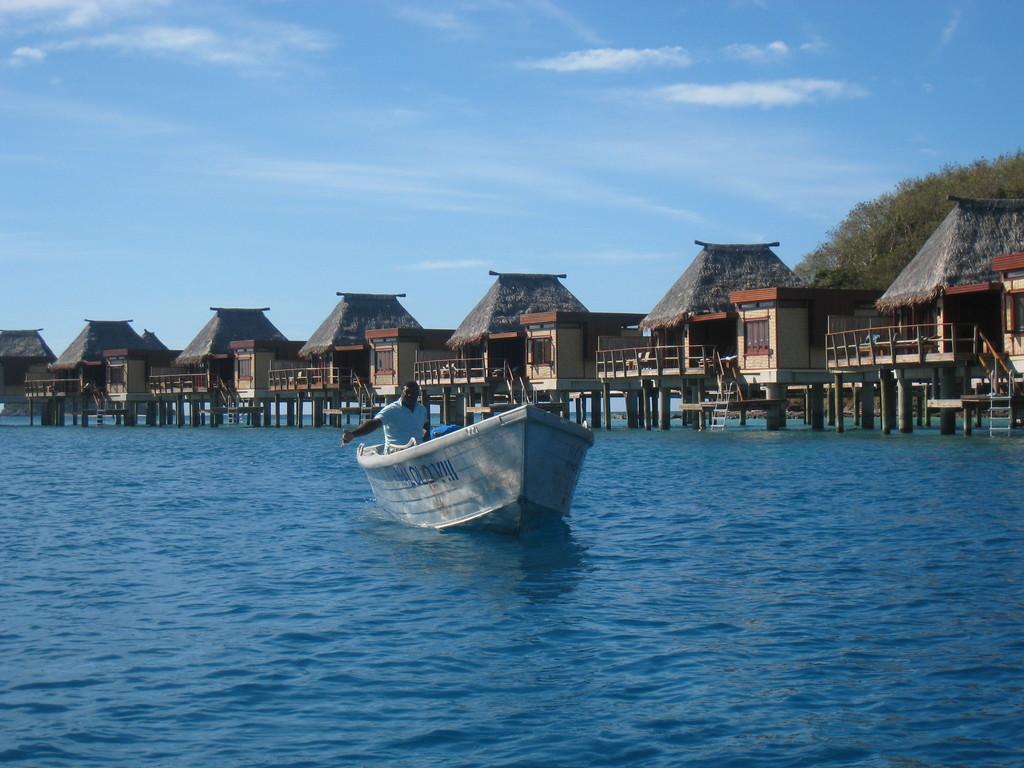Please provide a concise description of this image. The man in white T-shirt is sailing boat in the water. Behind that, there are huts and staircases. On the right corner of the picture, we see trees. At the top of the picture, we see the sky and at the bottom of the picture, we see water. This water might be in a sea. 